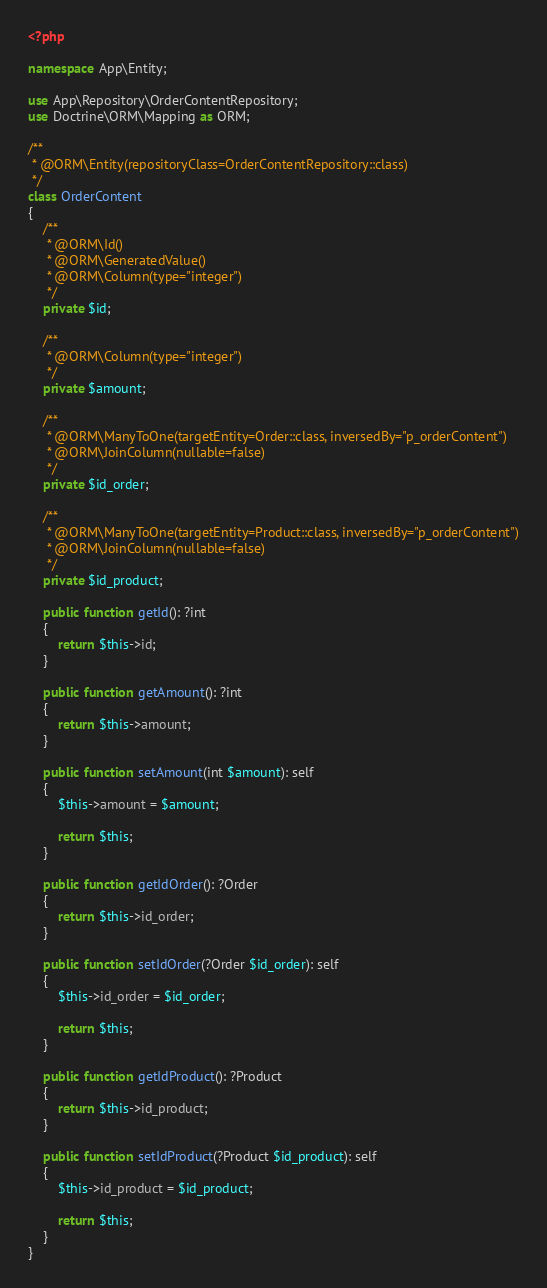Convert code to text. <code><loc_0><loc_0><loc_500><loc_500><_PHP_><?php

namespace App\Entity;

use App\Repository\OrderContentRepository;
use Doctrine\ORM\Mapping as ORM;

/**
 * @ORM\Entity(repositoryClass=OrderContentRepository::class)
 */
class OrderContent
{
    /**
     * @ORM\Id()
     * @ORM\GeneratedValue()
     * @ORM\Column(type="integer")
     */
    private $id;

    /**
     * @ORM\Column(type="integer")
     */
    private $amount;

    /**
     * @ORM\ManyToOne(targetEntity=Order::class, inversedBy="p_orderContent")
     * @ORM\JoinColumn(nullable=false)
     */
    private $id_order;

    /**
     * @ORM\ManyToOne(targetEntity=Product::class, inversedBy="p_orderContent")
     * @ORM\JoinColumn(nullable=false)
     */
    private $id_product;

    public function getId(): ?int
    {
        return $this->id;
    }

    public function getAmount(): ?int
    {
        return $this->amount;
    }

    public function setAmount(int $amount): self
    {
        $this->amount = $amount;

        return $this;
    }

    public function getIdOrder(): ?Order
    {
        return $this->id_order;
    }

    public function setIdOrder(?Order $id_order): self
    {
        $this->id_order = $id_order;

        return $this;
    }

    public function getIdProduct(): ?Product
    {
        return $this->id_product;
    }

    public function setIdProduct(?Product $id_product): self
    {
        $this->id_product = $id_product;

        return $this;
    }
}
</code> 